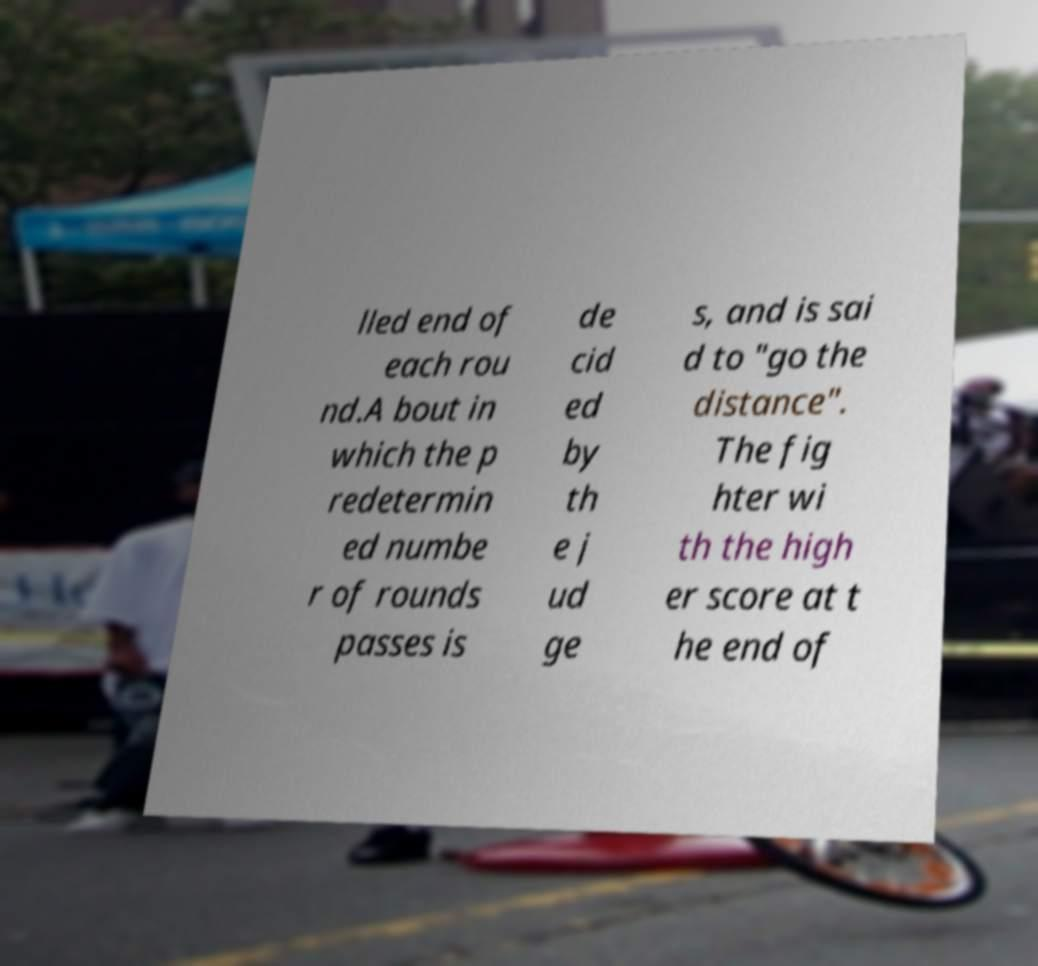Can you accurately transcribe the text from the provided image for me? lled end of each rou nd.A bout in which the p redetermin ed numbe r of rounds passes is de cid ed by th e j ud ge s, and is sai d to "go the distance". The fig hter wi th the high er score at t he end of 